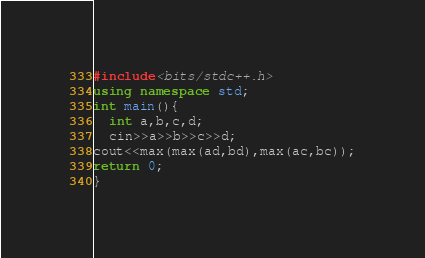Convert code to text. <code><loc_0><loc_0><loc_500><loc_500><_C++_>#include<bits/stdc++.h>
using namespace std;
int main(){
  int a,b,c,d;
  cin>>a>>b>>c>>d;
cout<<max(max(ad,bd),max(ac,bc));
return 0;
}</code> 